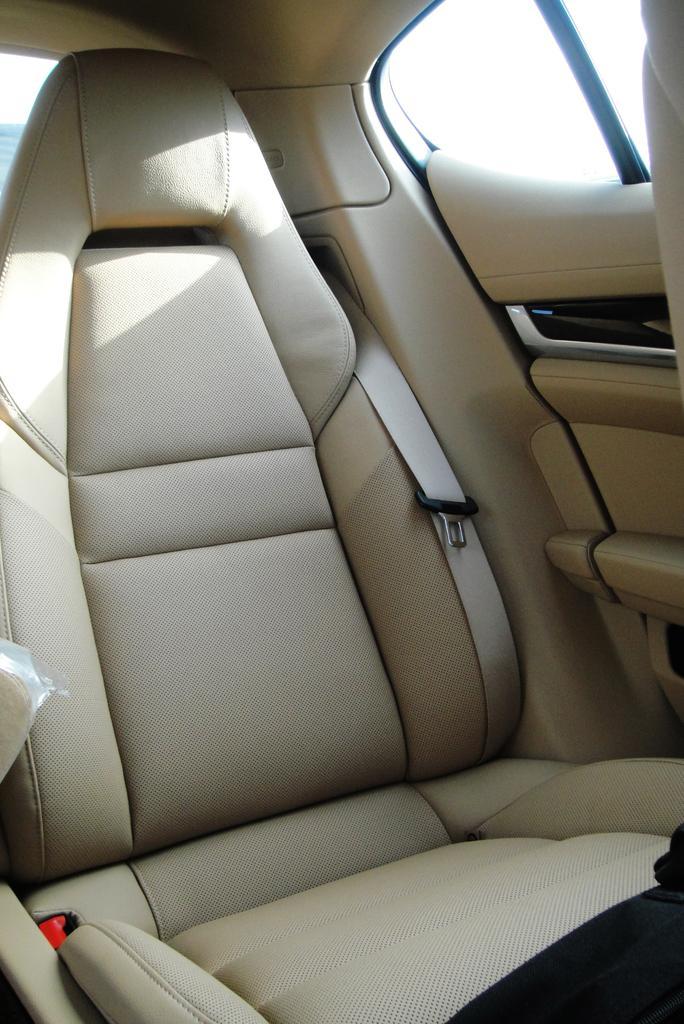Could you give a brief overview of what you see in this image? In this picture, we see the car seat. It is in white color. Beside that, we see the seat belt. On the right side, we see the car door and the glass window. This picture is clicked inside the car. 